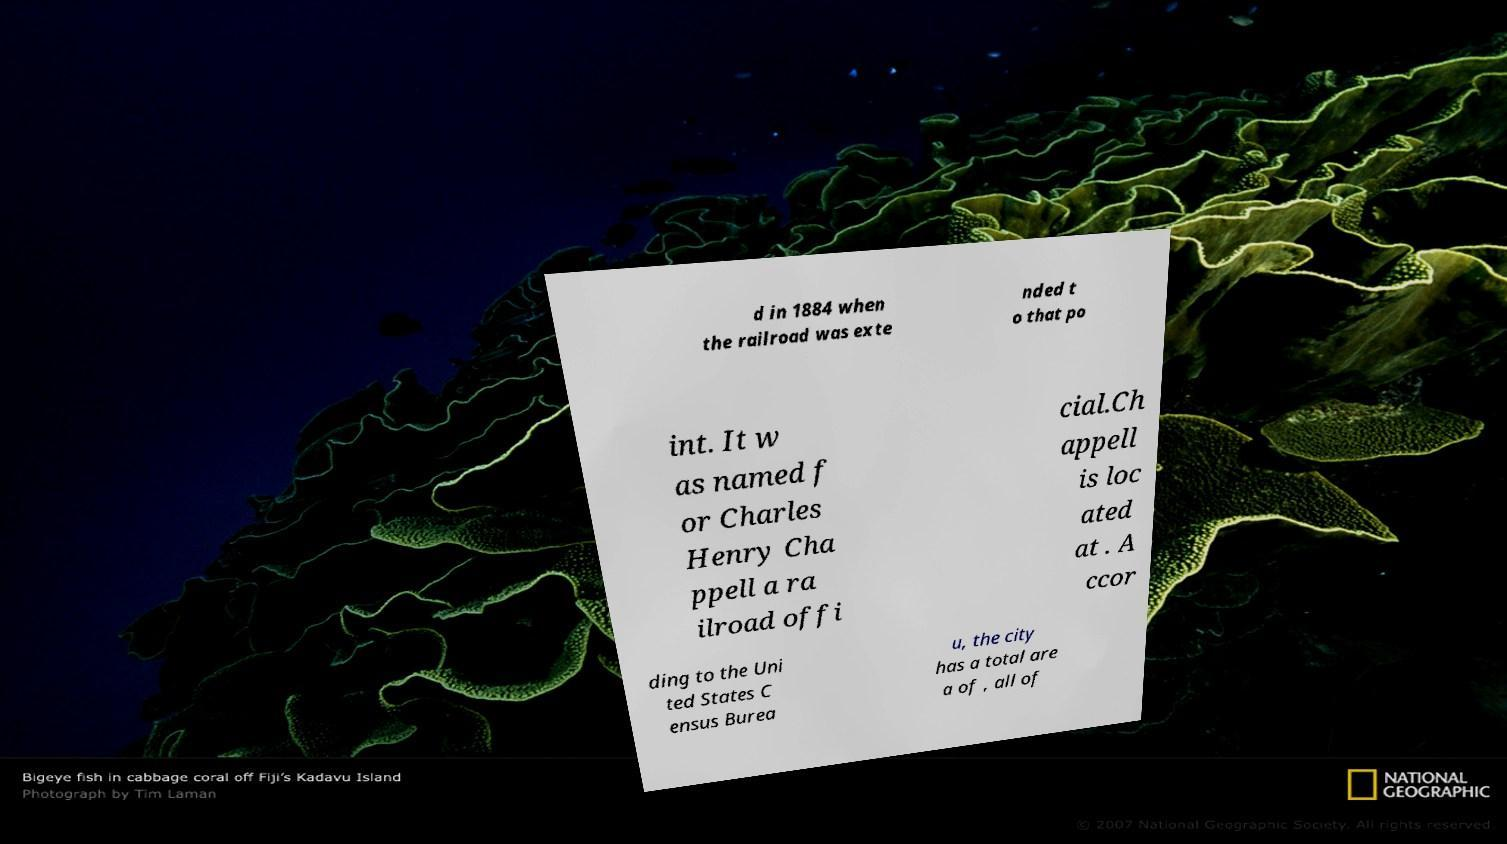Please identify and transcribe the text found in this image. d in 1884 when the railroad was exte nded t o that po int. It w as named f or Charles Henry Cha ppell a ra ilroad offi cial.Ch appell is loc ated at . A ccor ding to the Uni ted States C ensus Burea u, the city has a total are a of , all of 